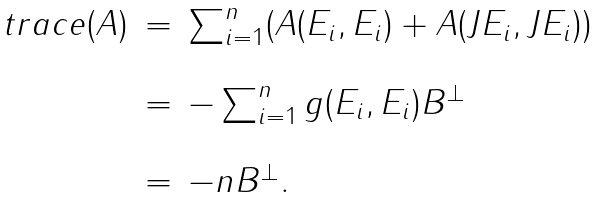<formula> <loc_0><loc_0><loc_500><loc_500>\begin{array} { l l l } t r a c e ( A ) & = & \sum _ { i = 1 } ^ { n } ( A ( E _ { i } , E _ { i } ) + A ( J E _ { i } , J E _ { i } ) ) \\ \\ & = & - \sum _ { i = 1 } ^ { n } g ( E _ { i } , E _ { i } ) B ^ { \perp } \\ \\ & = & - n B ^ { \perp } . \end{array}</formula> 